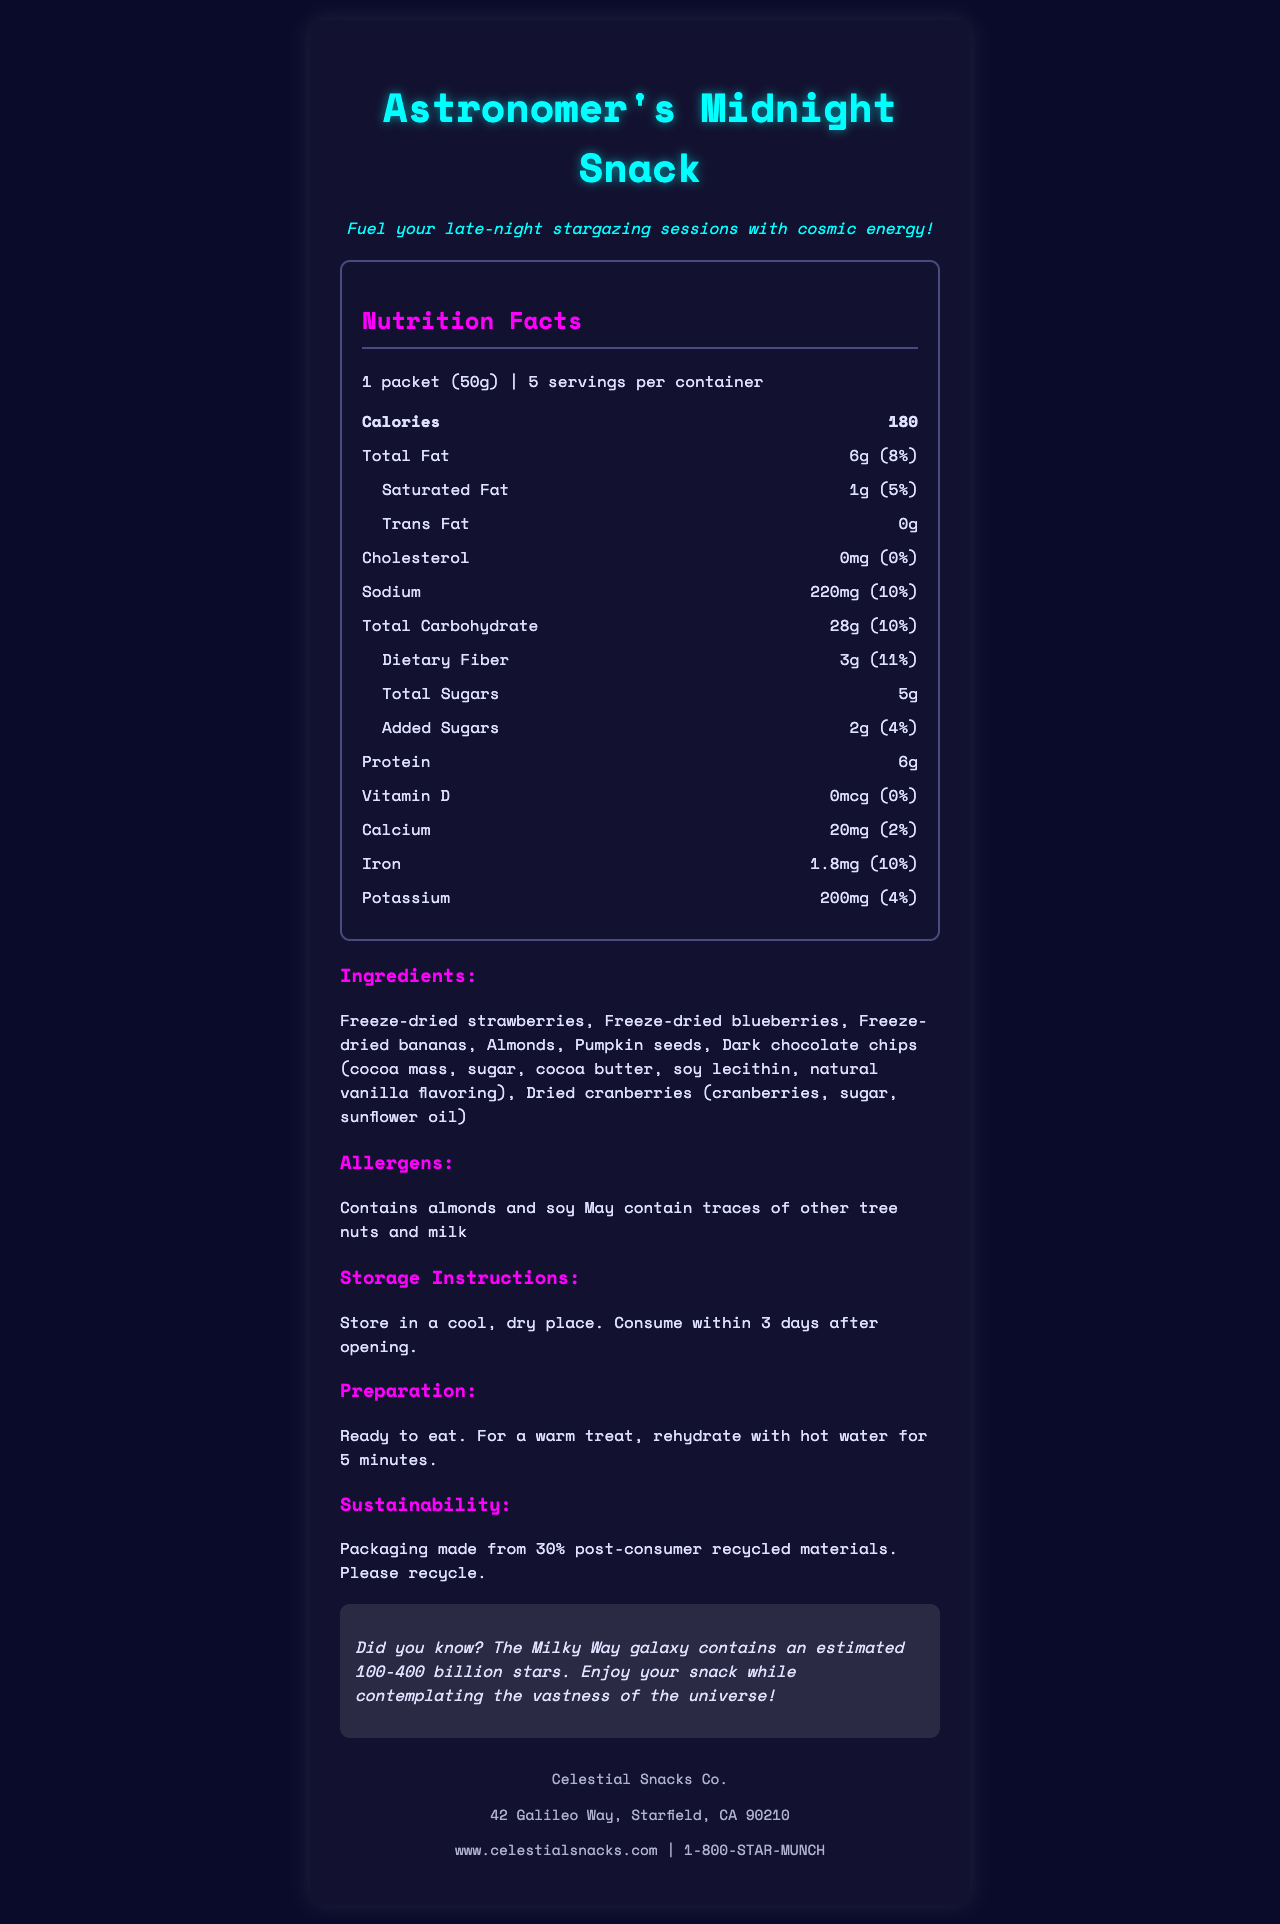what is the serving size? The document states that the serving size is "1 packet (50g)".
Answer: 1 packet (50g) how many servings are there per container? The document specifies "5 servings per container."
Answer: 5 how many calories are in one serving? The document lists "180 calories" under the nutrition facts.
Answer: 180 what is the amount of dietary fiber per serving? The document shows that each serving contains "3g" of dietary fiber.
Answer: 3g which ingredient provides the dark chocolate flavor? The ingredients list includes "Dark chocolate chips" which contain cocoa mass, sugar, cocoa butter, soy lecithin, and natural vanilla flavoring.
Answer: Dark chocolate chips what is the daily value percentage of iron in one serving? The document indicates that the iron content in one serving is "1.8mg (10%)".
Answer: 10% how much sodium is in one serving? The nutrition facts state that there are "220mg" of sodium per serving.
Answer: 220mg how many total sugars are in one serving? The document lists total sugars as "5g".
Answer: 5g does the Astronomer's Midnight Snack contain trans fat? Under the nutrition facts, trans fat is listed as "0g", indicating no trans fat.
Answer: No is there any cholesterol in this product? The document states that the cholesterol amount is "0mg (0%)".
Answer: No which company produces the Astronomer's Midnight Snack? A. Cosmic Bites Co. B. Celestial Snacks Co. C. Galactic Treats Ltd. The company information at the bottom of the document lists the name as "Celestial Snacks Co."
Answer: B. Celestial Snacks Co. which of the following ingredients is a potential allergen in this product? I. Almonds II. Soy III. Milk A. I only B. I and II only C. I, II, and III The allergens section mentions "Contains almonds and soy" and "May contain traces of other tree nuts and milk".
Answer: B. I and II only how should the product be stored after opening? The storage instructions state, "Store in a cool, dry place. Consume within 3 days after opening."
Answer: Consume within 3 days after opening is the product ready to eat, or does it require preparation? The preparation instructions indicate that the product is "Ready to eat. For a warm treat, rehydrate with hot water for 5 minutes."
Answer: Ready to eat what is the packaging made from? The sustainability note mentions that the packaging is made from "30% post-consumer recycled materials."
Answer: 30% post-consumer recycled materials how should the product be called if someone is avoiding bureaucratic paperwork? The persona customization special note mentions, "Perfect for those long nights avoiding bureaucratic paperwork while pursuing your true passion."
Answer: Astronomer's Midnight Snack what type of flavored oil is used in the dried cranberries? The ingredients list shows that the dried cranberries contain "cranberries, sugar, sunflower oil."
Answer: Sunflower oil how much potassium does one serving provide? The nutrition facts state that each serving contains "200mg" of potassium which is 4% of the daily value.
Answer: 200mg does the packaging have any visual designs? The packaging description says it's a "Resealable pouch with a starry night sky design featuring constellations and nebulae."
Answer: Yes summarize the main idea of the document. The document provides detailed information about the Astronomer's Midnight Snack including nutritional content, serving size, ingredients, allergen information, and sustainability note, along with preparation and storage instructions. The packaging is starry night-themed, aligning with its celestial branding.
Answer: The Astronomer's Midnight Snack is a freeze-dried snack specially designed for late-night star-gazing, with nutritional facts, ingredients, allergens, storage, and preparation instructions. The snack comes in a starry night-themed resealable pouch and is produced by Celestial Snacks Co. what is the full address of the Celestial Snacks Co.? The company information section lists the address as "42 Galileo Way, Starfield, CA 90210."
Answer: 42 Galileo Way, Starfield, CA 90210 what is the phone number for customer service? The company information provides the customer service number as "1-800-STAR-MUNCH."
Answer: 1-800-STAR-MUNCH what percentage of daily value does the total carbohydrate in one serving correspond to? The document states that the total carbohydrate content is "28g (10%)".
Answer: 10% does the product contain peanuts? The document lists "almonds and soy" as specific allergens and mentions that it may contain traces of other tree nuts and milk, but does not provide information about peanuts specifically.
Answer: Not enough information 